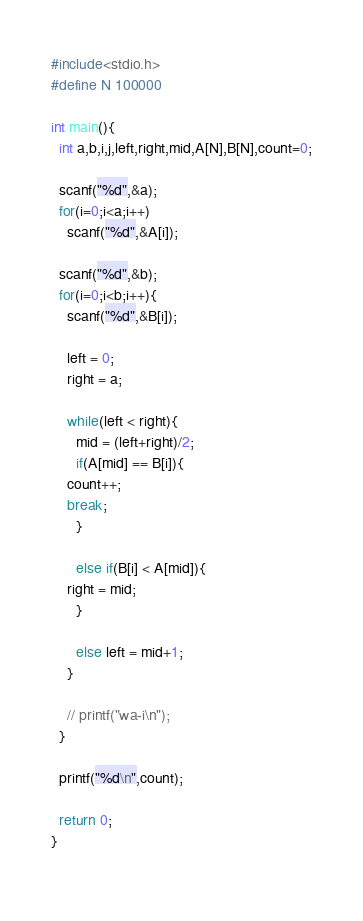Convert code to text. <code><loc_0><loc_0><loc_500><loc_500><_C_>#include<stdio.h>
#define N 100000

int main(){
  int a,b,i,j,left,right,mid,A[N],B[N],count=0;

  scanf("%d",&a);
  for(i=0;i<a;i++)
    scanf("%d",&A[i]);

  scanf("%d",&b);
  for(i=0;i<b;i++){
    scanf("%d",&B[i]);
    
    left = 0;
    right = a;

    while(left < right){
      mid = (left+right)/2;
      if(A[mid] == B[i]){
	count++;
	break;
      }
      
      else if(B[i] < A[mid]){
	right = mid;
      }
      
      else left = mid+1;
    }
    
    // printf("wa-i\n");
  }
  
  printf("%d\n",count);
	
  return 0;
}
  

</code> 